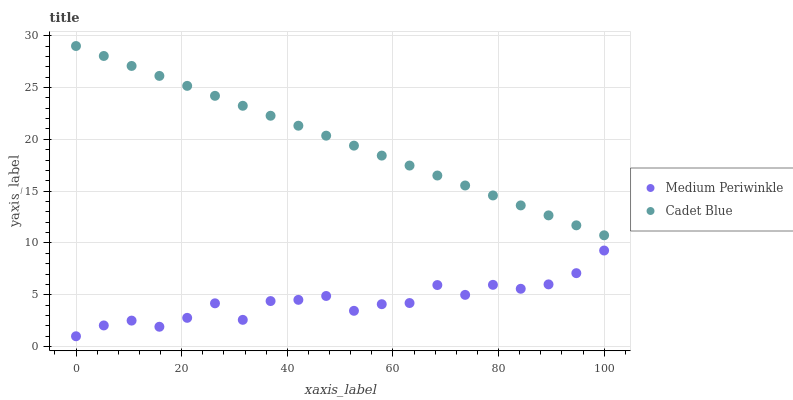Does Medium Periwinkle have the minimum area under the curve?
Answer yes or no. Yes. Does Cadet Blue have the maximum area under the curve?
Answer yes or no. Yes. Does Medium Periwinkle have the maximum area under the curve?
Answer yes or no. No. Is Cadet Blue the smoothest?
Answer yes or no. Yes. Is Medium Periwinkle the roughest?
Answer yes or no. Yes. Is Medium Periwinkle the smoothest?
Answer yes or no. No. Does Medium Periwinkle have the lowest value?
Answer yes or no. Yes. Does Cadet Blue have the highest value?
Answer yes or no. Yes. Does Medium Periwinkle have the highest value?
Answer yes or no. No. Is Medium Periwinkle less than Cadet Blue?
Answer yes or no. Yes. Is Cadet Blue greater than Medium Periwinkle?
Answer yes or no. Yes. Does Medium Periwinkle intersect Cadet Blue?
Answer yes or no. No. 